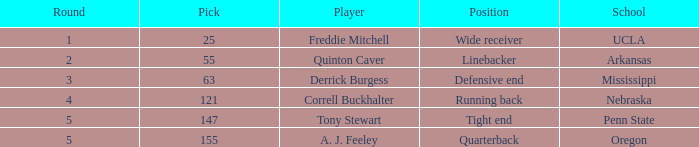Could you parse the entire table? {'header': ['Round', 'Pick', 'Player', 'Position', 'School'], 'rows': [['1', '25', 'Freddie Mitchell', 'Wide receiver', 'UCLA'], ['2', '55', 'Quinton Caver', 'Linebacker', 'Arkansas'], ['3', '63', 'Derrick Burgess', 'Defensive end', 'Mississippi'], ['4', '121', 'Correll Buckhalter', 'Running back', 'Nebraska'], ['5', '147', 'Tony Stewart', 'Tight end', 'Penn State'], ['5', '155', 'A. J. Feeley', 'Quarterback', 'Oregon']]} What position did a. j. feeley play who was picked in round 5? Quarterback. 